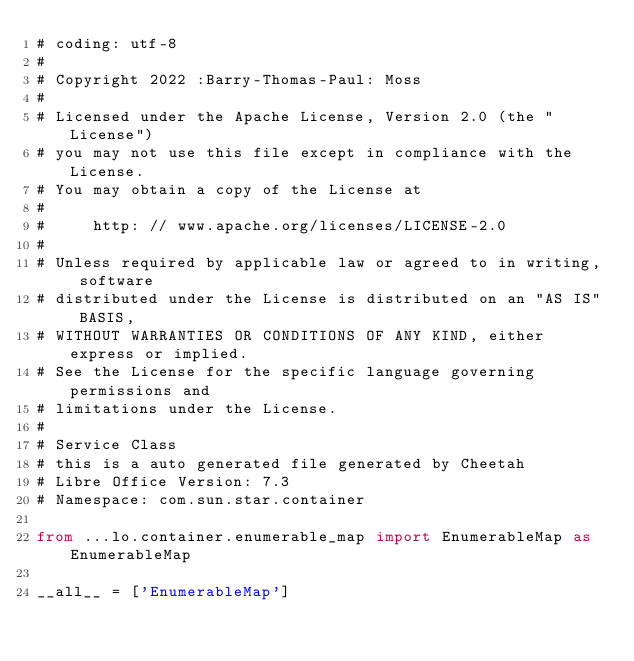<code> <loc_0><loc_0><loc_500><loc_500><_Python_># coding: utf-8
#
# Copyright 2022 :Barry-Thomas-Paul: Moss
#
# Licensed under the Apache License, Version 2.0 (the "License")
# you may not use this file except in compliance with the License.
# You may obtain a copy of the License at
#
#     http: // www.apache.org/licenses/LICENSE-2.0
#
# Unless required by applicable law or agreed to in writing, software
# distributed under the License is distributed on an "AS IS" BASIS,
# WITHOUT WARRANTIES OR CONDITIONS OF ANY KIND, either express or implied.
# See the License for the specific language governing permissions and
# limitations under the License.
#
# Service Class
# this is a auto generated file generated by Cheetah
# Libre Office Version: 7.3
# Namespace: com.sun.star.container

from ...lo.container.enumerable_map import EnumerableMap as EnumerableMap

__all__ = ['EnumerableMap']

</code> 